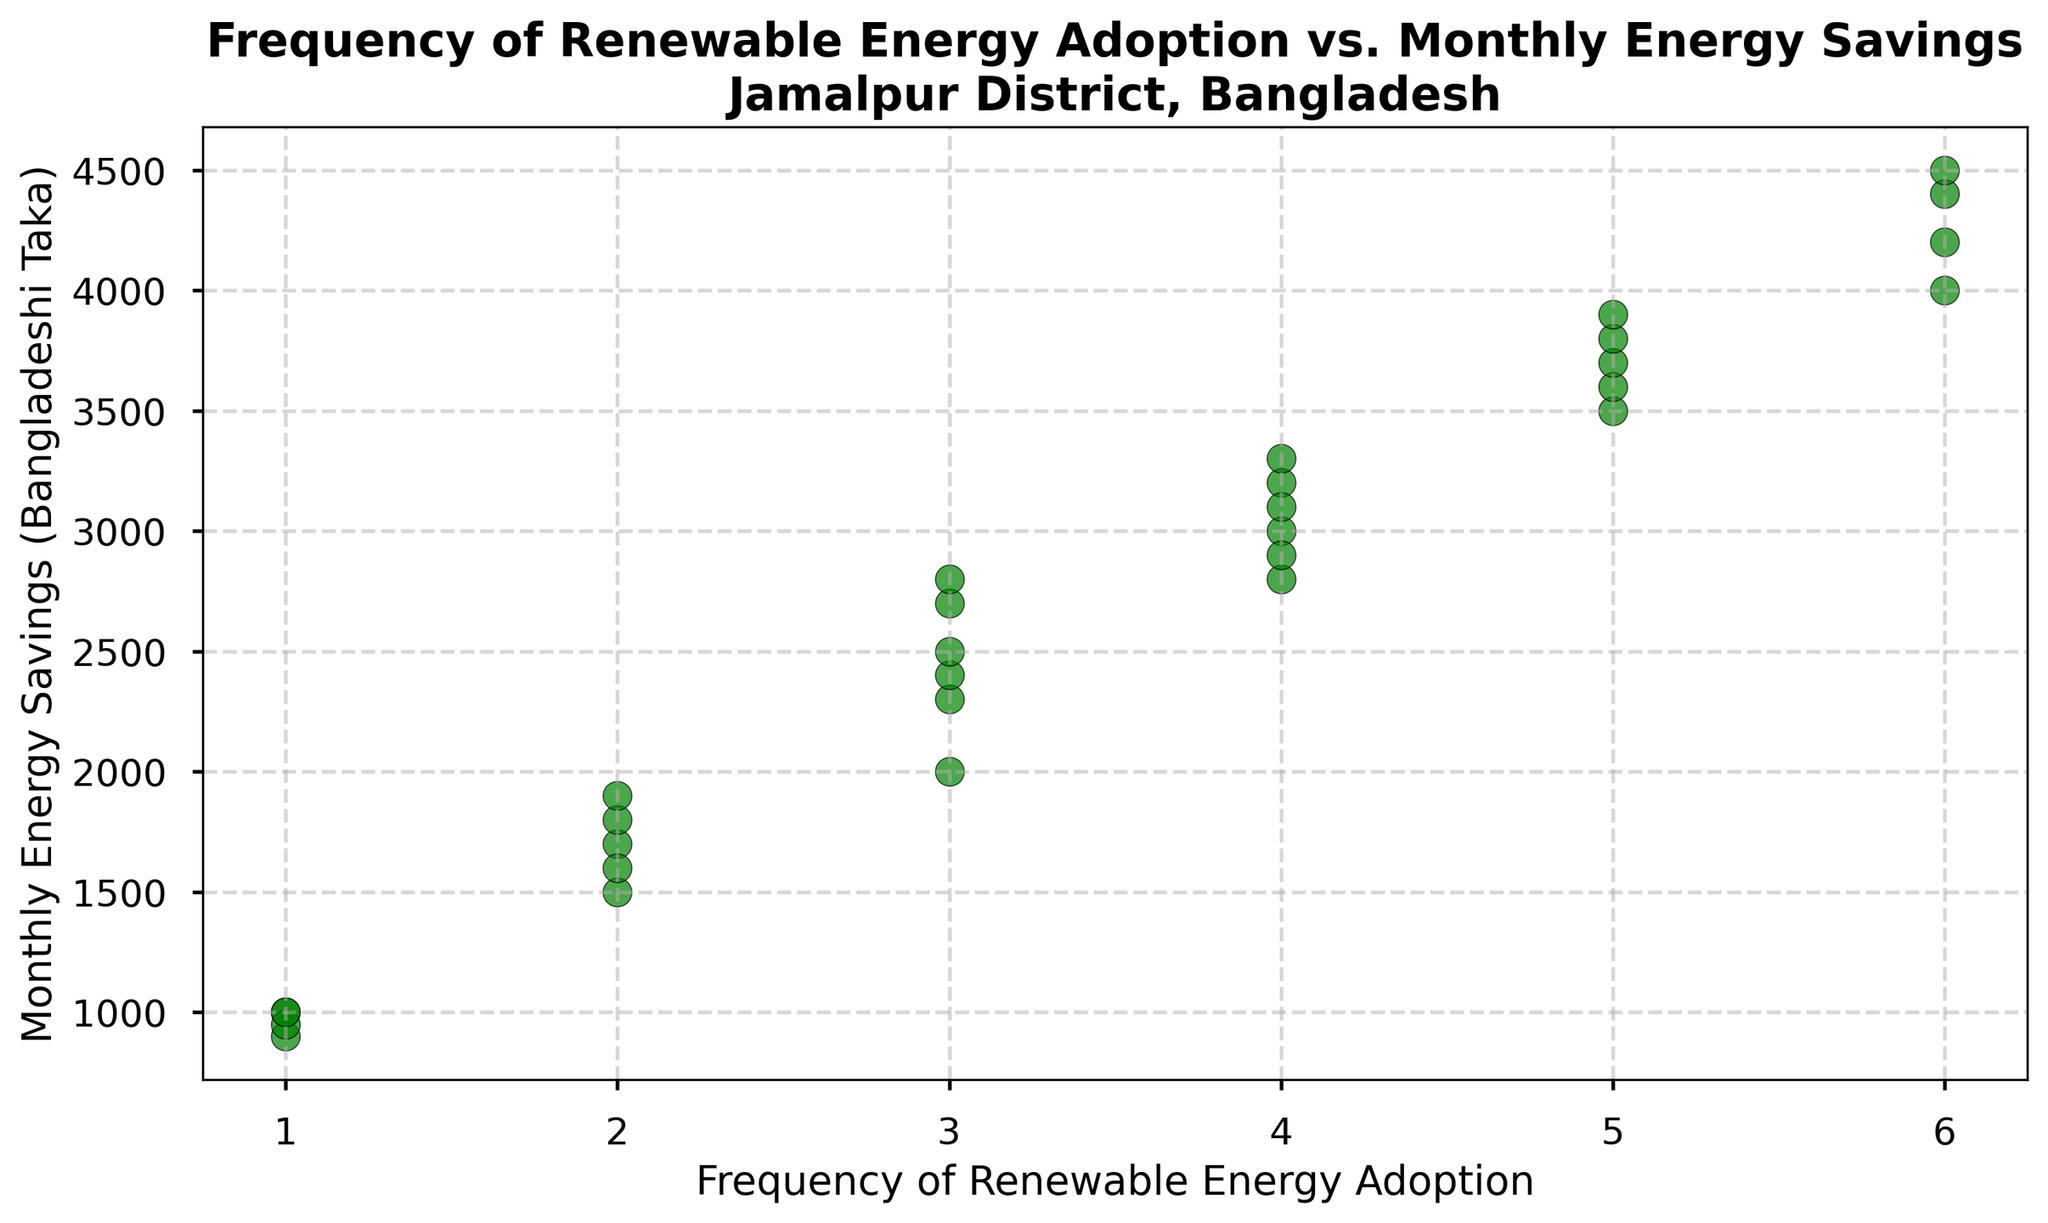Which frequency of renewable energy adoption has the highest average monthly energy savings? To find the frequency with the highest average savings, locate all points for each frequency, sum the monthly savings, and divide by the number of points. For frequency 6, monthly savings are (4000 + 4200 + 4400 + 4500) with 4 points meaning average = 4350. Compare this process for other frequencies.
Answer: 6 How many data points represent a frequency of renewable energy adoption of 3? Count the number of points with the x-coordinate (frequency) equal to 3. There are 5 such points.
Answer: 5 Which frequency of renewable energy adoption has the lowest minimum monthly energy savings? Identify the lowest monthly savings for each frequency by looking at the y-coordinate values. Frequency of 1: 900 and 1000, Frequency of 2: 1500, 1600, etc. The lowest minimum value is at frequency 1 with 900.
Answer: 1 What is the difference in monthly energy savings between the highest and lowest frequencies? Highest frequency: 6 has savings such as 4500. Lowest frequency: 1 has a point with 900. Difference = 4500 - 900.
Answer: 3600 How does the frequency of 4 compare to the frequency of 5 in terms of average monthly savings? Calculate the averages separately: Frequency 4: (2800 + 3000 + 2900 + 3200 + 3100 + 3300) / 6 equals approximately 3050. Frequency 5: (3500 + 3600 + 3700 + 3800 + 3900) / 5 equals 3700. Compare the averages.
Answer: Frequency 5 has higher average savings What does the plot suggest about the relationship between frequency of renewable energy adoption and monthly energy savings? Observing the scatter plot, it appears higher frequencies tend to cluster around higher savings values (e.g., 6 around 4000+), while lower frequencies cluster around lower savings (1 around 1000). This suggests a positive correlation between higher adoption and higher savings.
Answer: Positive correlation How many points on the scatter plot display monthly energy savings greater than 3000 Bangladeshi Taka? Count all data points with y-coordinates greater than 3000. Points above 3000 include those with savings like 3500, 3600, up to 4500. Count these points.
Answer: 14 For frequencies of renewable energy adoption greater than 3, what is the average monthly energy savings? Sum up monthly savings for frequencies 4, 5, and 6: (2800 + 3000 + 2900 + 3200 + 3100 + 3300 + 3500 + 3600 + 3700 + 3800 + 3900 + 4000 + 4200 + 4400 + 4500). There are 14 points, and the total is 56600, so average = 56600 / 14.
Answer: 4042.86 What's the range of monthly energy savings for a frequency of 2? Identify the minimum and maximum values of savings for frequency 2. They are 1500, 1600, 1700, 1800, 1900. The range is the difference between the maximum and minimum.
Answer: 1900 - 1500 = 400 Which frequency of renewable energy adoption shows the most variability in monthly energy savings? Examine the spread of values (range) for each frequency. For instance, frequency 1: 900 to 1000, frequency 2: 1500 to 1900, etc. The frequency with the largest difference indicates the most variability.
Answer: 6 